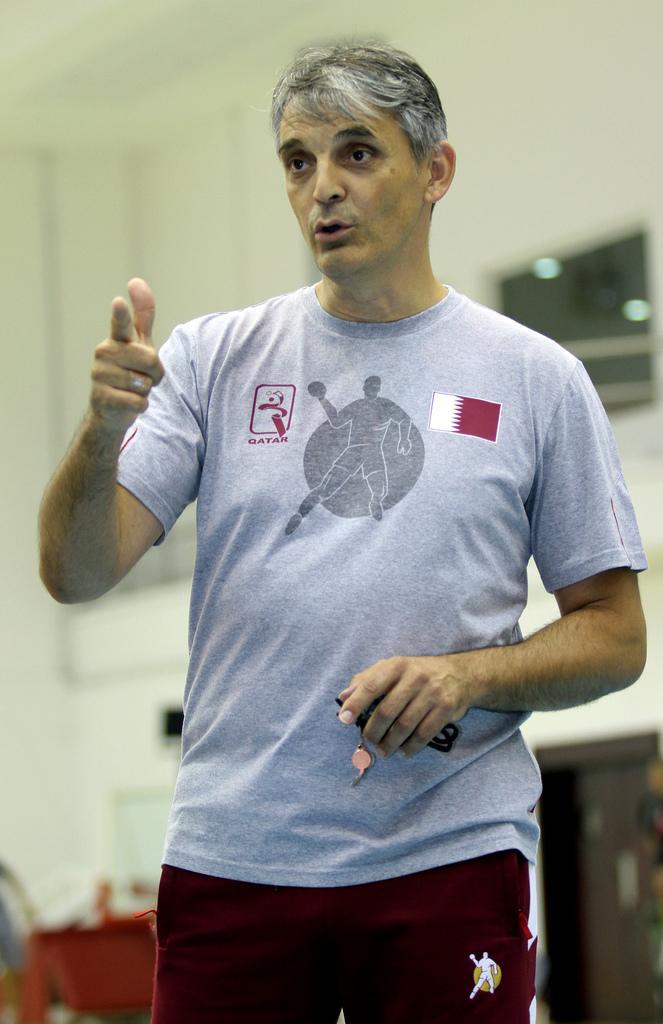Please provide a concise description of this image. In this image we can see there is a person standing in room holding keys in hand, behind him there is a wall. 